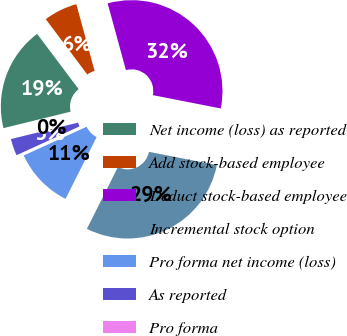Convert chart. <chart><loc_0><loc_0><loc_500><loc_500><pie_chart><fcel>Net income (loss) as reported<fcel>Add stock-based employee<fcel>Deduct stock-based employee<fcel>Incremental stock option<fcel>Pro forma net income (loss)<fcel>As reported<fcel>Pro forma<nl><fcel>18.58%<fcel>6.0%<fcel>32.33%<fcel>29.34%<fcel>10.76%<fcel>3.0%<fcel>0.0%<nl></chart> 